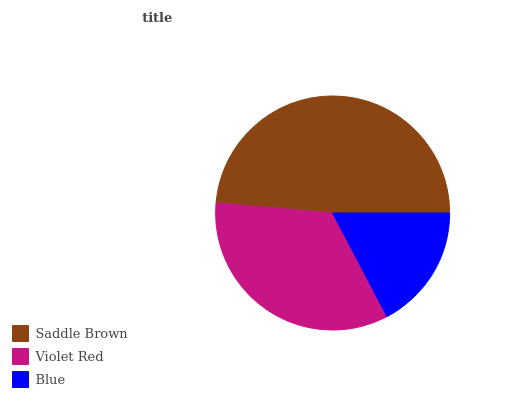Is Blue the minimum?
Answer yes or no. Yes. Is Saddle Brown the maximum?
Answer yes or no. Yes. Is Violet Red the minimum?
Answer yes or no. No. Is Violet Red the maximum?
Answer yes or no. No. Is Saddle Brown greater than Violet Red?
Answer yes or no. Yes. Is Violet Red less than Saddle Brown?
Answer yes or no. Yes. Is Violet Red greater than Saddle Brown?
Answer yes or no. No. Is Saddle Brown less than Violet Red?
Answer yes or no. No. Is Violet Red the high median?
Answer yes or no. Yes. Is Violet Red the low median?
Answer yes or no. Yes. Is Saddle Brown the high median?
Answer yes or no. No. Is Saddle Brown the low median?
Answer yes or no. No. 